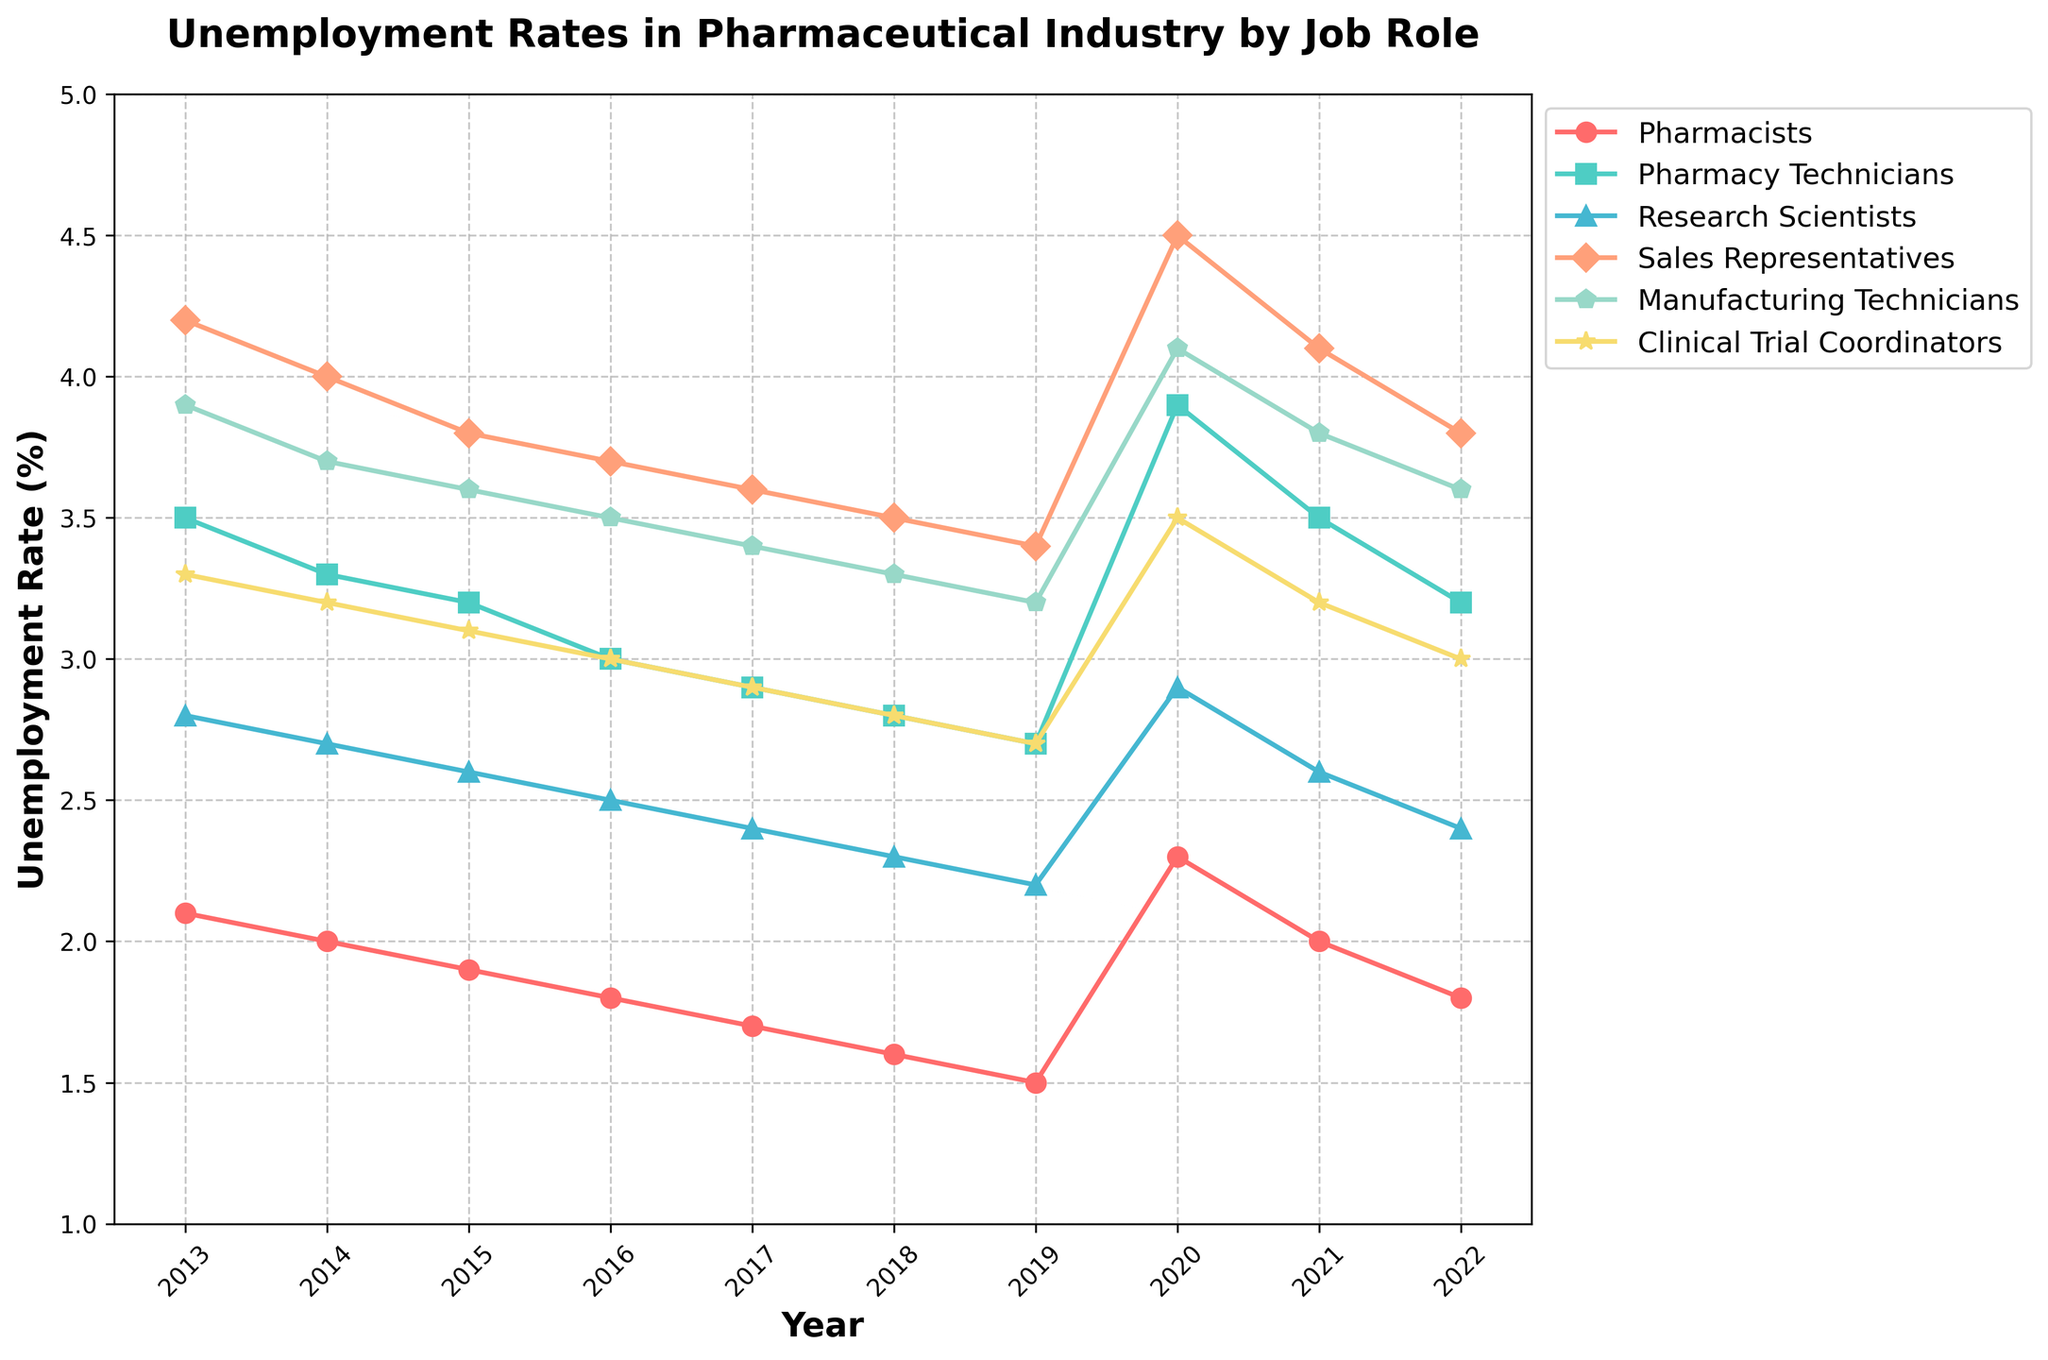What is the trend for unemployment rates of Pharmacists from 2013 to 2022? To find the trend, observe the line representing Pharmacists from 2013 to 2022. It starts at 2.1% in 2013 and ends at 1.8% in 2022, with a notable peak of 2.3% in 2020. Overall, the rate decreases over the decade, despite a temporary spike in 2020.
Answer: Decreasing trend with a peak in 2020 Which job role had the highest unemployment rate in 2020? Look at the 2020 data points for all job roles and identify the highest one. The Sales Representatives had the highest rate at 4.5%.
Answer: Sales Representatives Compare the unemployment rates of Research Scientists and Manufacturing Technicians in 2017. Which one was higher and by how much? In 2017, Research Scientists had a rate of 2.4% while Manufacturing Technicians had a rate of 3.4%. The difference is 3.4% - 2.4% = 1%.
Answer: Manufacturing Technicians by 1% What is the average unemployment rate of Pharmacy Technicians over the decade? Add all the unemployment rates for Pharmacy Technicians from 2013 to 2022 and divide by the number of years (10). The sum is 3.5 + 3.3 + 3.2 + 3.0 + 2.9 + 2.8 + 2.7 + 3.9 + 3.5 + 3.2 = 32.0. So, the average is 32.0/10 = 3.2%.
Answer: 3.2% How does the unemployment rate of Clinical Trial Coordinators in 2015 compare to that in 2019? In 2015, the rate was 3.1%, and in 2019, it was 2.7%. Compare these values to see that the rate decreased by 0.4%.
Answer: Decreased by 0.4% What is the maximum unemployment rate observed for Manufacturing Technicians in the given period? Locate the highest point in the data for Manufacturing Technicians. The highest rate is observed in 2020 at 4.1%.
Answer: 4.1% Describe the change in unemployment rates for Sales Representatives between 2018 and 2020. In 2018, the rate was 3.5%, which increased to 4.5% in 2020. To quantify the change, subtract 3.5% from 4.5%, resulting in an increase of 1%.
Answer: Increased by 1% Which role consistently had the lowest unemployment rate from 2013 to 2022? Observe the unemployment rates for all roles over the entire period. Pharmacists consistently had the lowest rate, starting at 2.1% in 2013 and dropping to 1.8% in 2022, with a minimum value of 1.5% in 2019.
Answer: Pharmacists In which year did the unemployment rate peak for Clinical Trial Coordinators, and what was the rate? Look for the highest point in the unemployment rate line for Clinical Trial Coordinators. The peak occurred in 2020, with a rate of 3.5%.
Answer: 2020, 3.5% 